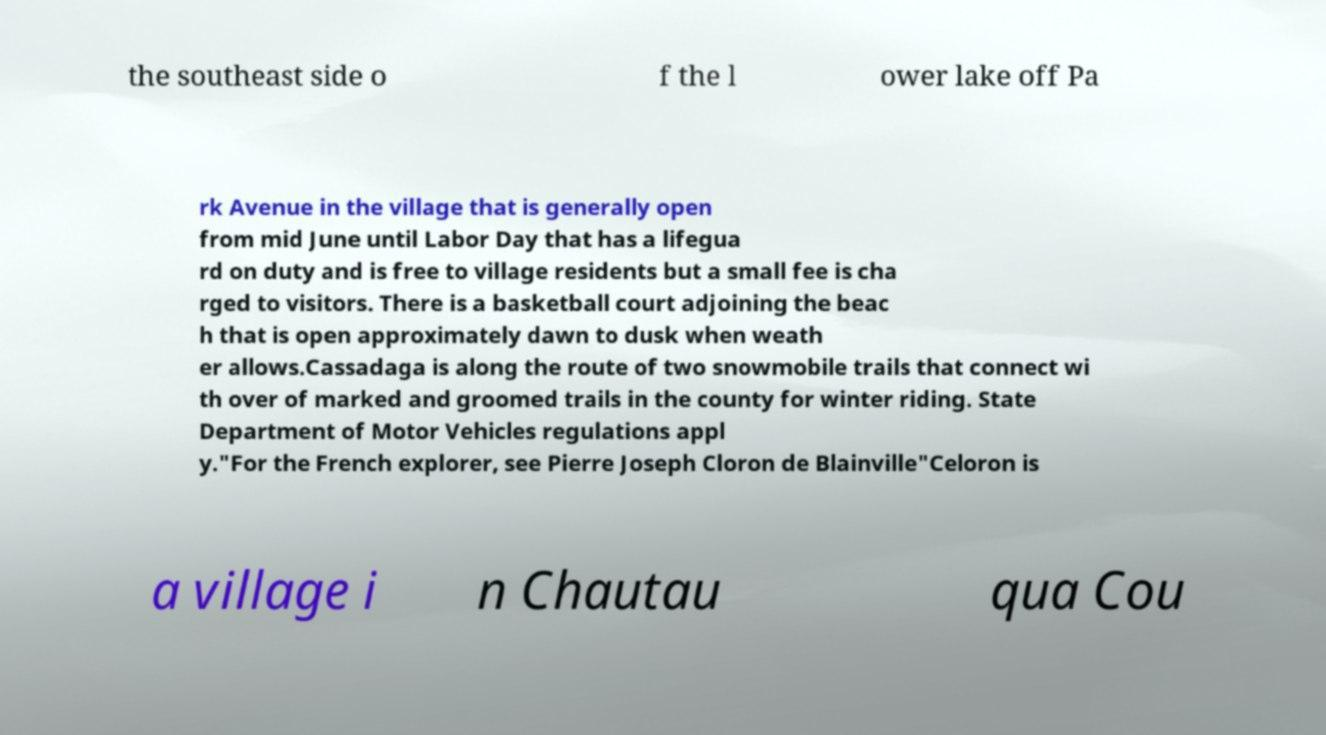I need the written content from this picture converted into text. Can you do that? the southeast side o f the l ower lake off Pa rk Avenue in the village that is generally open from mid June until Labor Day that has a lifegua rd on duty and is free to village residents but a small fee is cha rged to visitors. There is a basketball court adjoining the beac h that is open approximately dawn to dusk when weath er allows.Cassadaga is along the route of two snowmobile trails that connect wi th over of marked and groomed trails in the county for winter riding. State Department of Motor Vehicles regulations appl y."For the French explorer, see Pierre Joseph Cloron de Blainville"Celoron is a village i n Chautau qua Cou 